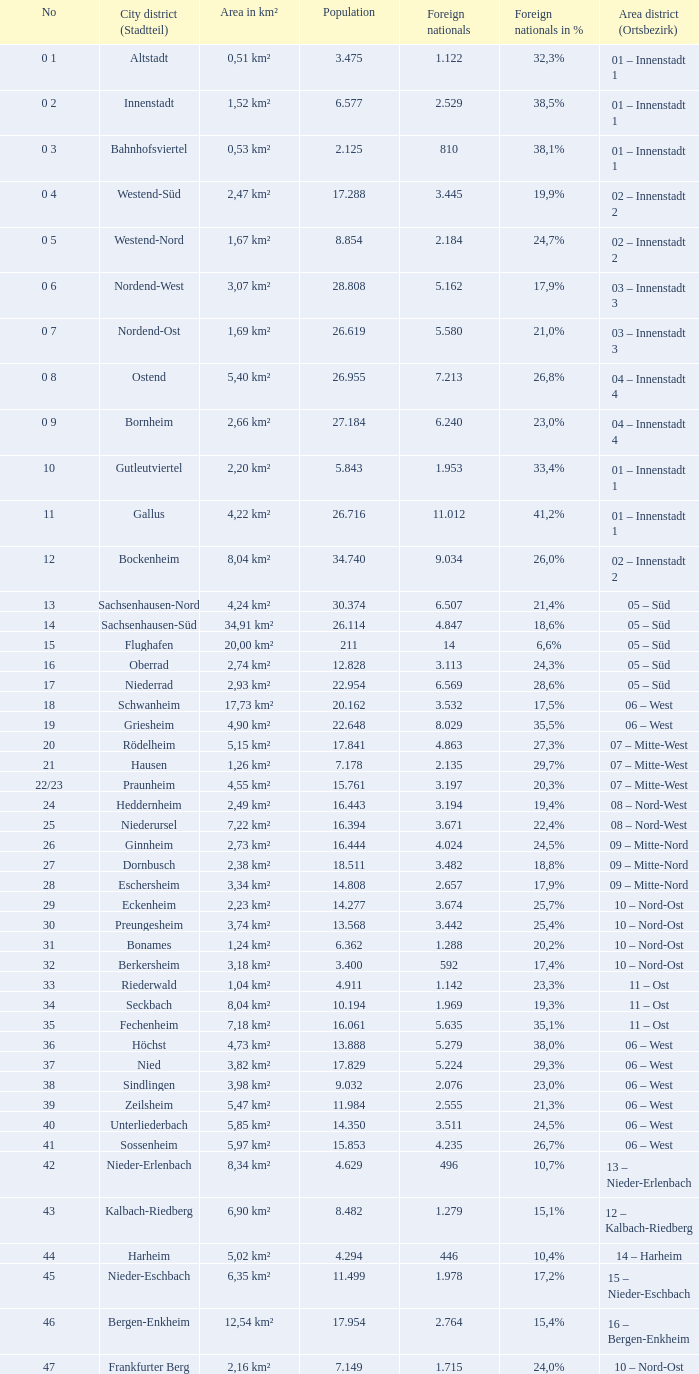In which city district or stadtteil is the foreigner population 5,162? 1.0. Help me parse the entirety of this table. {'header': ['No', 'City district (Stadtteil)', 'Area in km²', 'Population', 'Foreign nationals', 'Foreign nationals in %', 'Area district (Ortsbezirk)'], 'rows': [['0 1', 'Altstadt', '0,51 km²', '3.475', '1.122', '32,3%', '01 – Innenstadt 1'], ['0 2', 'Innenstadt', '1,52 km²', '6.577', '2.529', '38,5%', '01 – Innenstadt 1'], ['0 3', 'Bahnhofsviertel', '0,53 km²', '2.125', '810', '38,1%', '01 – Innenstadt 1'], ['0 4', 'Westend-Süd', '2,47 km²', '17.288', '3.445', '19,9%', '02 – Innenstadt 2'], ['0 5', 'Westend-Nord', '1,67 km²', '8.854', '2.184', '24,7%', '02 – Innenstadt 2'], ['0 6', 'Nordend-West', '3,07 km²', '28.808', '5.162', '17,9%', '03 – Innenstadt 3'], ['0 7', 'Nordend-Ost', '1,69 km²', '26.619', '5.580', '21,0%', '03 – Innenstadt 3'], ['0 8', 'Ostend', '5,40 km²', '26.955', '7.213', '26,8%', '04 – Innenstadt 4'], ['0 9', 'Bornheim', '2,66 km²', '27.184', '6.240', '23,0%', '04 – Innenstadt 4'], ['10', 'Gutleutviertel', '2,20 km²', '5.843', '1.953', '33,4%', '01 – Innenstadt 1'], ['11', 'Gallus', '4,22 km²', '26.716', '11.012', '41,2%', '01 – Innenstadt 1'], ['12', 'Bockenheim', '8,04 km²', '34.740', '9.034', '26,0%', '02 – Innenstadt 2'], ['13', 'Sachsenhausen-Nord', '4,24 km²', '30.374', '6.507', '21,4%', '05 – Süd'], ['14', 'Sachsenhausen-Süd', '34,91 km²', '26.114', '4.847', '18,6%', '05 – Süd'], ['15', 'Flughafen', '20,00 km²', '211', '14', '6,6%', '05 – Süd'], ['16', 'Oberrad', '2,74 km²', '12.828', '3.113', '24,3%', '05 – Süd'], ['17', 'Niederrad', '2,93 km²', '22.954', '6.569', '28,6%', '05 – Süd'], ['18', 'Schwanheim', '17,73 km²', '20.162', '3.532', '17,5%', '06 – West'], ['19', 'Griesheim', '4,90 km²', '22.648', '8.029', '35,5%', '06 – West'], ['20', 'Rödelheim', '5,15 km²', '17.841', '4.863', '27,3%', '07 – Mitte-West'], ['21', 'Hausen', '1,26 km²', '7.178', '2.135', '29,7%', '07 – Mitte-West'], ['22/23', 'Praunheim', '4,55 km²', '15.761', '3.197', '20,3%', '07 – Mitte-West'], ['24', 'Heddernheim', '2,49 km²', '16.443', '3.194', '19,4%', '08 – Nord-West'], ['25', 'Niederursel', '7,22 km²', '16.394', '3.671', '22,4%', '08 – Nord-West'], ['26', 'Ginnheim', '2,73 km²', '16.444', '4.024', '24,5%', '09 – Mitte-Nord'], ['27', 'Dornbusch', '2,38 km²', '18.511', '3.482', '18,8%', '09 – Mitte-Nord'], ['28', 'Eschersheim', '3,34 km²', '14.808', '2.657', '17,9%', '09 – Mitte-Nord'], ['29', 'Eckenheim', '2,23 km²', '14.277', '3.674', '25,7%', '10 – Nord-Ost'], ['30', 'Preungesheim', '3,74 km²', '13.568', '3.442', '25,4%', '10 – Nord-Ost'], ['31', 'Bonames', '1,24 km²', '6.362', '1.288', '20,2%', '10 – Nord-Ost'], ['32', 'Berkersheim', '3,18 km²', '3.400', '592', '17,4%', '10 – Nord-Ost'], ['33', 'Riederwald', '1,04 km²', '4.911', '1.142', '23,3%', '11 – Ost'], ['34', 'Seckbach', '8,04 km²', '10.194', '1.969', '19,3%', '11 – Ost'], ['35', 'Fechenheim', '7,18 km²', '16.061', '5.635', '35,1%', '11 – Ost'], ['36', 'Höchst', '4,73 km²', '13.888', '5.279', '38,0%', '06 – West'], ['37', 'Nied', '3,82 km²', '17.829', '5.224', '29,3%', '06 – West'], ['38', 'Sindlingen', '3,98 km²', '9.032', '2.076', '23,0%', '06 – West'], ['39', 'Zeilsheim', '5,47 km²', '11.984', '2.555', '21,3%', '06 – West'], ['40', 'Unterliederbach', '5,85 km²', '14.350', '3.511', '24,5%', '06 – West'], ['41', 'Sossenheim', '5,97 km²', '15.853', '4.235', '26,7%', '06 – West'], ['42', 'Nieder-Erlenbach', '8,34 km²', '4.629', '496', '10,7%', '13 – Nieder-Erlenbach'], ['43', 'Kalbach-Riedberg', '6,90 km²', '8.482', '1.279', '15,1%', '12 – Kalbach-Riedberg'], ['44', 'Harheim', '5,02 km²', '4.294', '446', '10,4%', '14 – Harheim'], ['45', 'Nieder-Eschbach', '6,35 km²', '11.499', '1.978', '17,2%', '15 – Nieder-Eschbach'], ['46', 'Bergen-Enkheim', '12,54 km²', '17.954', '2.764', '15,4%', '16 – Bergen-Enkheim'], ['47', 'Frankfurter Berg', '2,16 km²', '7.149', '1.715', '24,0%', '10 – Nord-Ost']]} 